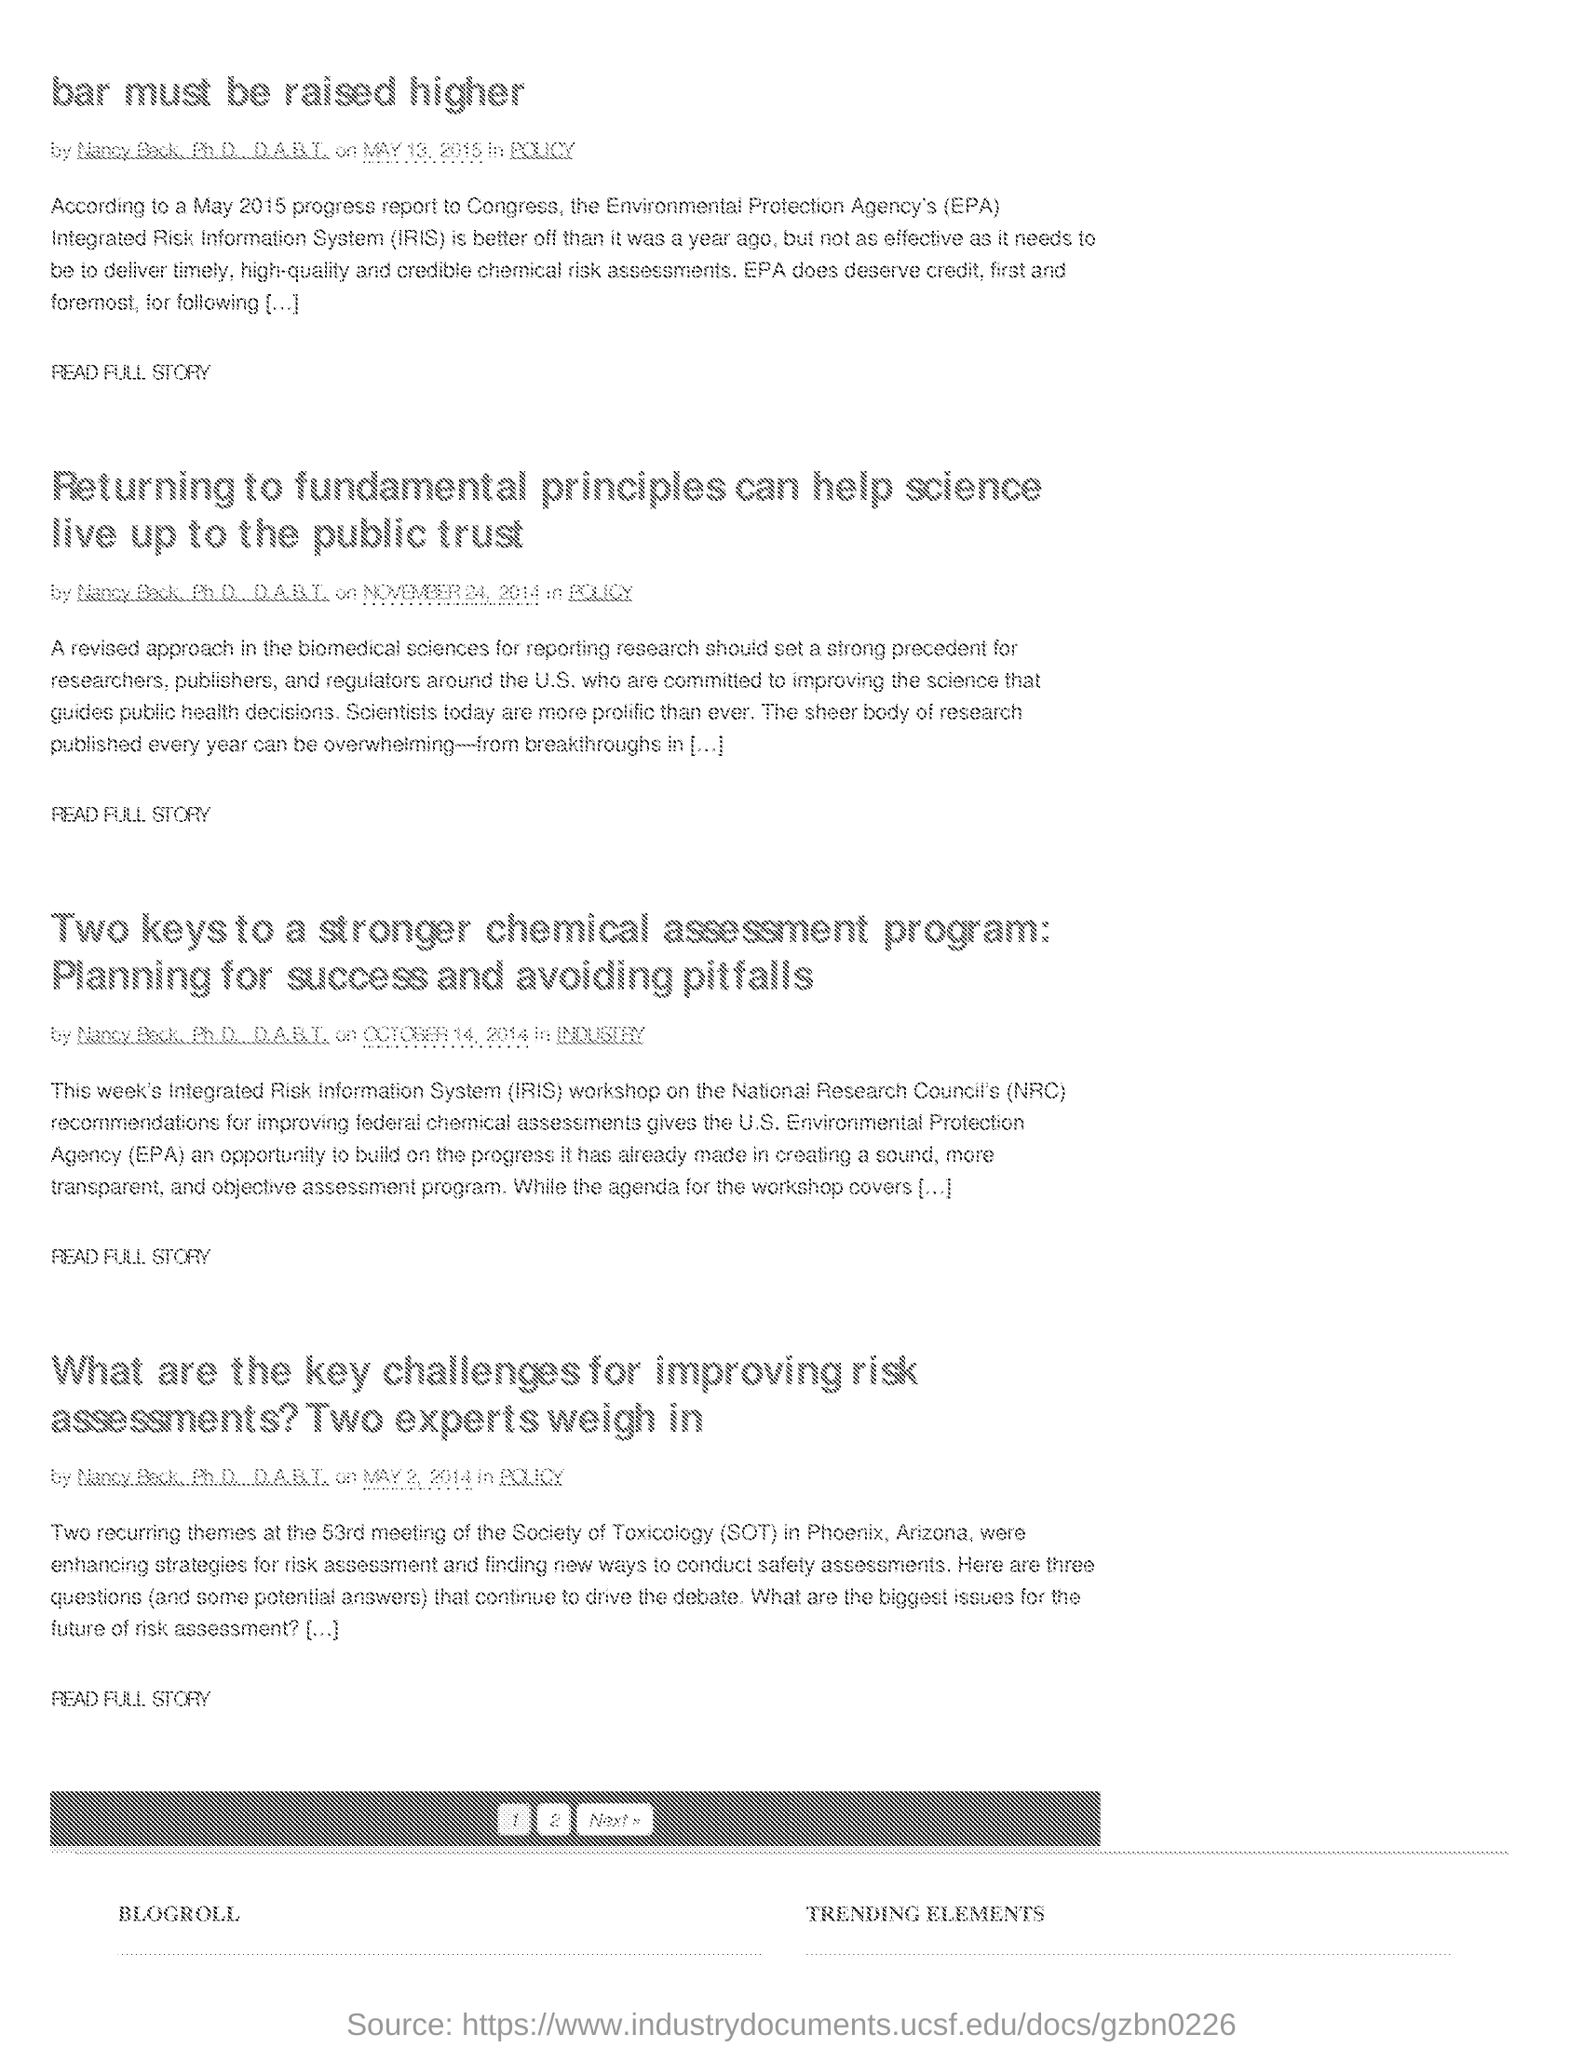Indicate a few pertinent items in this graphic. The IRIS acronym stands for Integrated Risk Information System, which is a comprehensive database that contains information on various types of risks and associated mitigation strategies. The 53rd meeting of the Society of Toxicology was held in Phoenix, Arizona. 